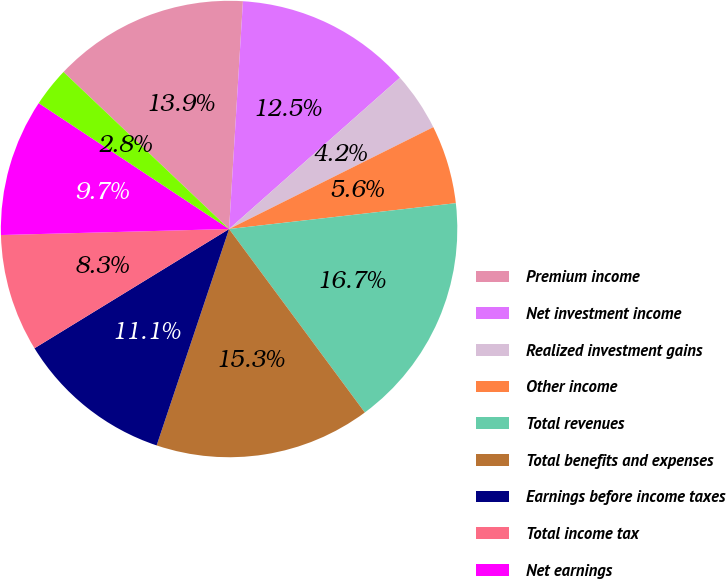<chart> <loc_0><loc_0><loc_500><loc_500><pie_chart><fcel>Premium income<fcel>Net investment income<fcel>Realized investment gains<fcel>Other income<fcel>Total revenues<fcel>Total benefits and expenses<fcel>Earnings before income taxes<fcel>Total income tax<fcel>Net earnings<fcel>Net earnings per basic share<nl><fcel>13.89%<fcel>12.5%<fcel>4.17%<fcel>5.56%<fcel>16.67%<fcel>15.28%<fcel>11.11%<fcel>8.33%<fcel>9.72%<fcel>2.78%<nl></chart> 